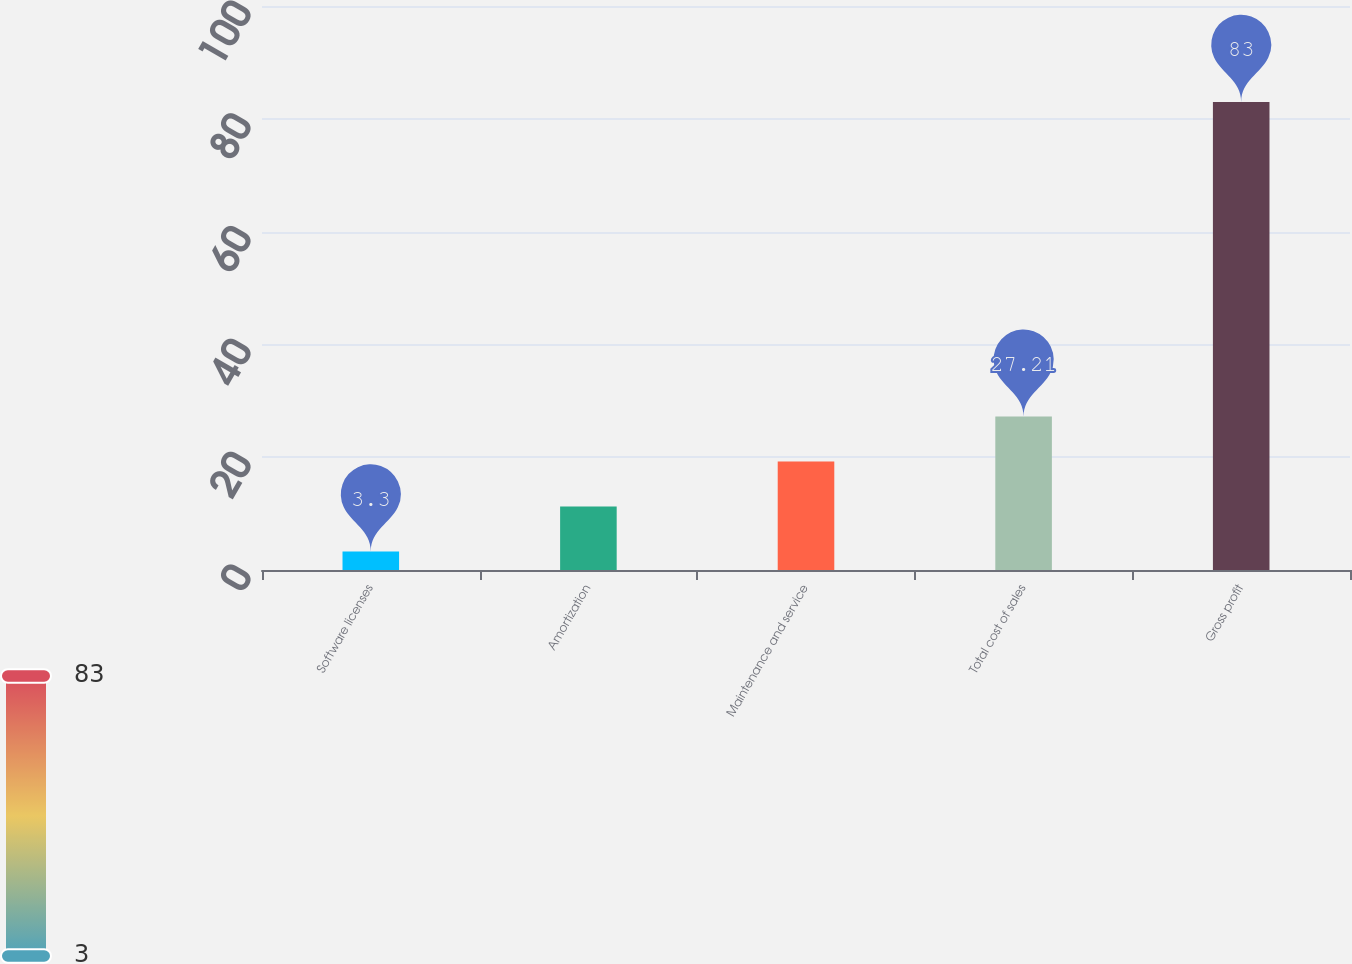<chart> <loc_0><loc_0><loc_500><loc_500><bar_chart><fcel>Software licenses<fcel>Amortization<fcel>Maintenance and service<fcel>Total cost of sales<fcel>Gross profit<nl><fcel>3.3<fcel>11.27<fcel>19.24<fcel>27.21<fcel>83<nl></chart> 